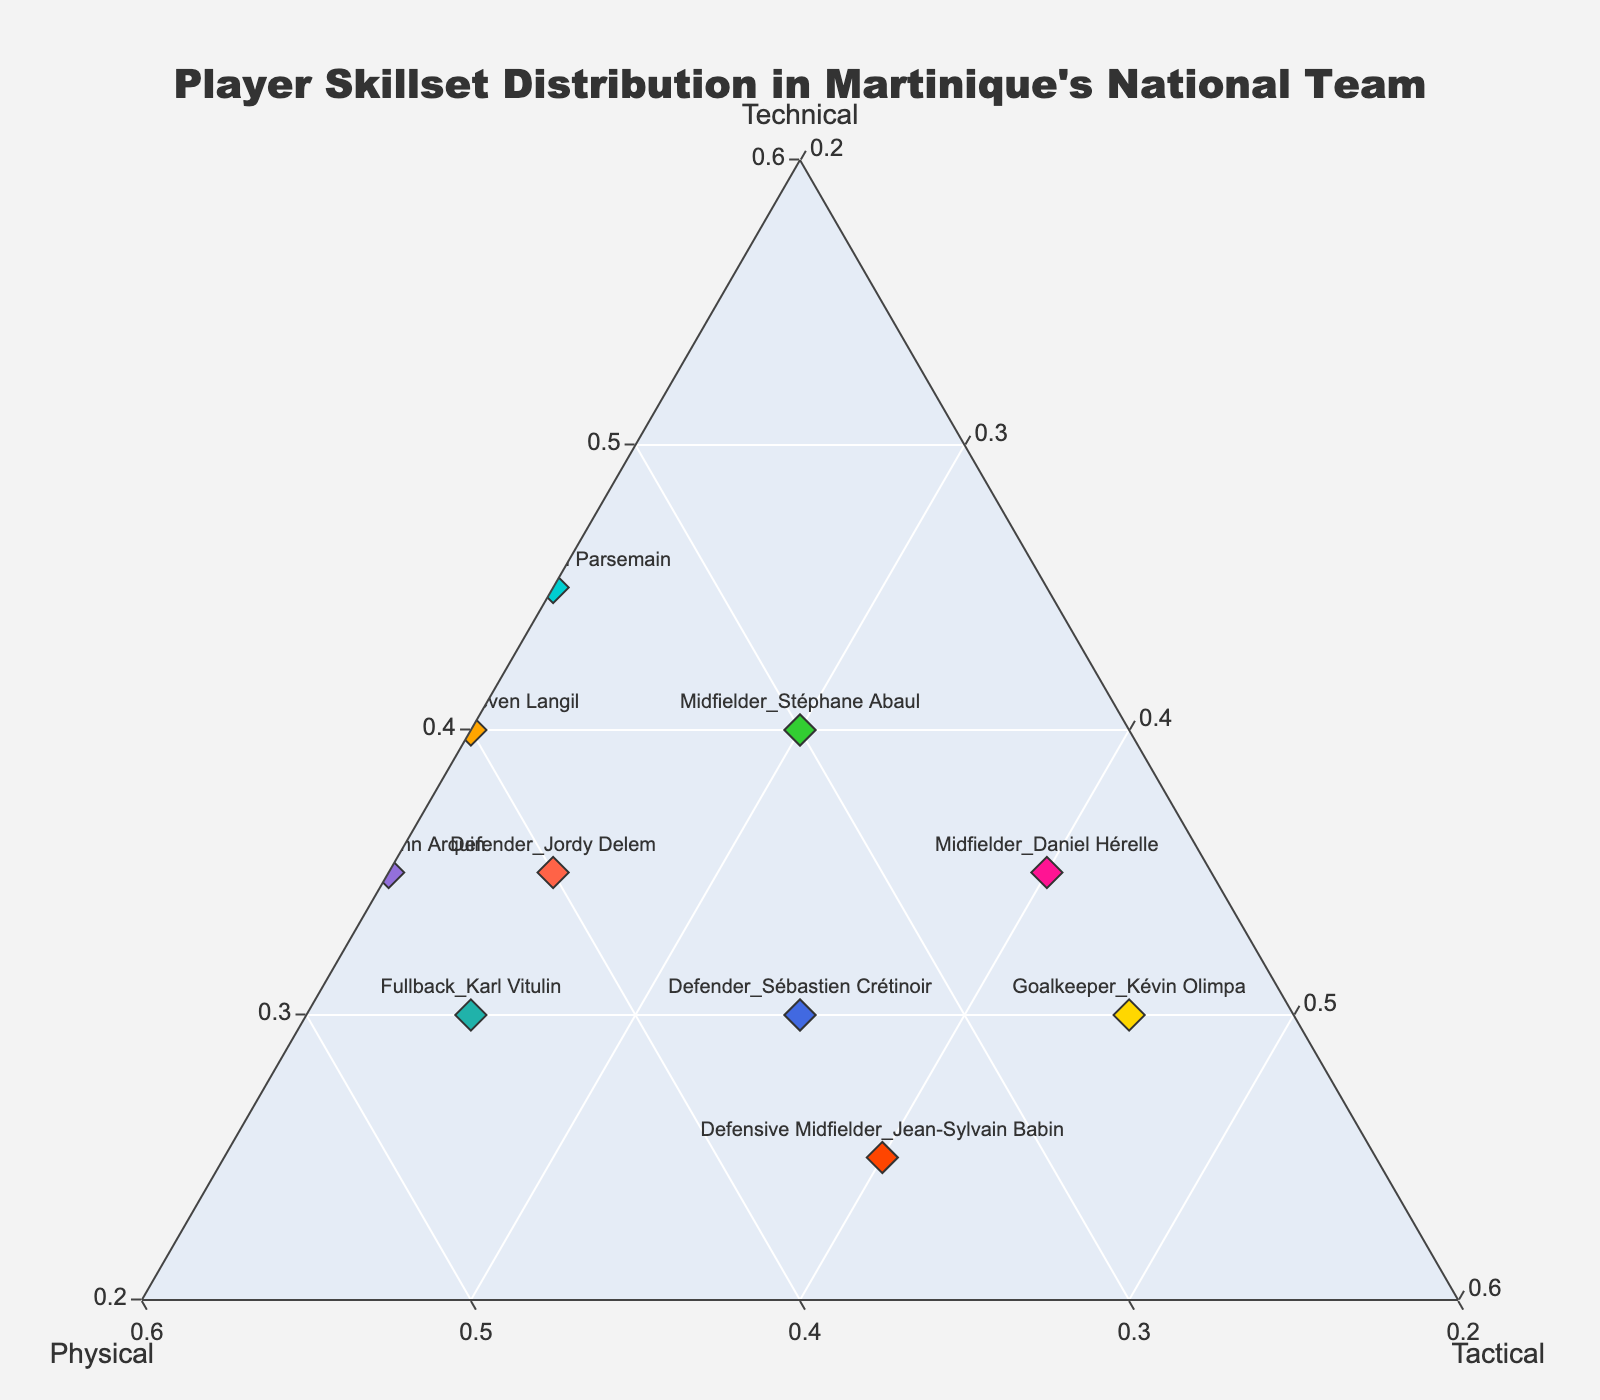What is the title of the ternary plot? The title of the plot is typically displayed at the top part of the figure.
Answer: Player Skillset Distribution in Martinique's National Team How many players have a higher Tactical skill than Technical skill? Count the number of players who have a higher value in the Tactical axis compared to the Technical axis. There are three players with higher Tactical skills: Goalkeeper_Kévin Olimpa, Defensive Midfielder_Jean-Sylvain Babin, and Midfielder_Daniel Hérelle.
Answer: 3 Which player has the highest Technical skill? Look for the player with the highest value on the Technical axis of the ternary plot. Forward_Kévin Parsemain has the highest Technical skill.
Answer: Forward_Kévin Parsemain How do the Technical and Physical skills of Midfielder_Stéphane Abaul compare? Stéphane Abaul's Technical skill is 0.40 and his Physical skill is 0.30. Since 0.40 is greater than 0.30, his Technical skill is higher than his Physical skill.
Answer: Technical skill is higher Which player emphasizes Physical skill the most? Identify the player with the highest value on the Physical axis of the ternary plot. Winger_Yoann Arquin has the highest Physical skill.
Answer: Winger_Yoann Arquin Compare the Tactical skills of Goalkeeper_Kévin Olimpa and Forward_Steeven Langil. Who has better Tactical skills? Goalkeeper_Kévin Olimpa has a Tactical skill of 0.45 while Forward_Steeven Langil has a Tactical skill of 0.20. Since 0.45 is greater than 0.20, Goalkeeper_Kévin Olimpa has better Tactical skills.
Answer: Goalkeeper_Kévin Olimpa Is there any player whose Technical, Physical, and Tactical skills are exactly equal? Examine all the points on the ternary plot and check if any of them lie exactly at the center of the plot (where Technical = Physical = Tactical). No player has exactly equal Technical, Physical, and Tactical skills.
Answer: No What is the sum of Technical and Tactical skills for Defender_Jordy Delem? Jordy Delem's Technical skill is 0.35 and Tactical skill is 0.25. Sum these values: 0.35 + 0.25 = 0.60.
Answer: 0.60 Which positions mostly see a balance between Tactical and Physical skills? Check the ternary plot for positions where values for Tactical and Physical are fairly close to each other. Defender_Sébastien Crétinoir and Defensive Midfielder_Jean-Sylvain Babin have roughly balanced Tactical and Physical skills.
Answer: Defender_Sébastien Crétinoir, Defensive Midfielder_Jean-Sylvain Babin 